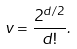Convert formula to latex. <formula><loc_0><loc_0><loc_500><loc_500>v = \frac { 2 ^ { d / 2 } } { d ! } .</formula> 